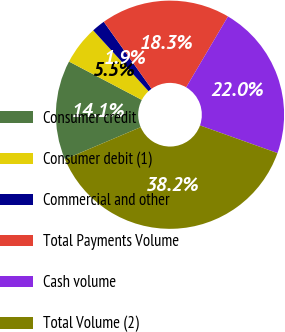Convert chart. <chart><loc_0><loc_0><loc_500><loc_500><pie_chart><fcel>Consumer credit<fcel>Consumer debit (1)<fcel>Commercial and other<fcel>Total Payments Volume<fcel>Cash volume<fcel>Total Volume (2)<nl><fcel>14.1%<fcel>5.53%<fcel>1.9%<fcel>18.34%<fcel>21.97%<fcel>38.16%<nl></chart> 